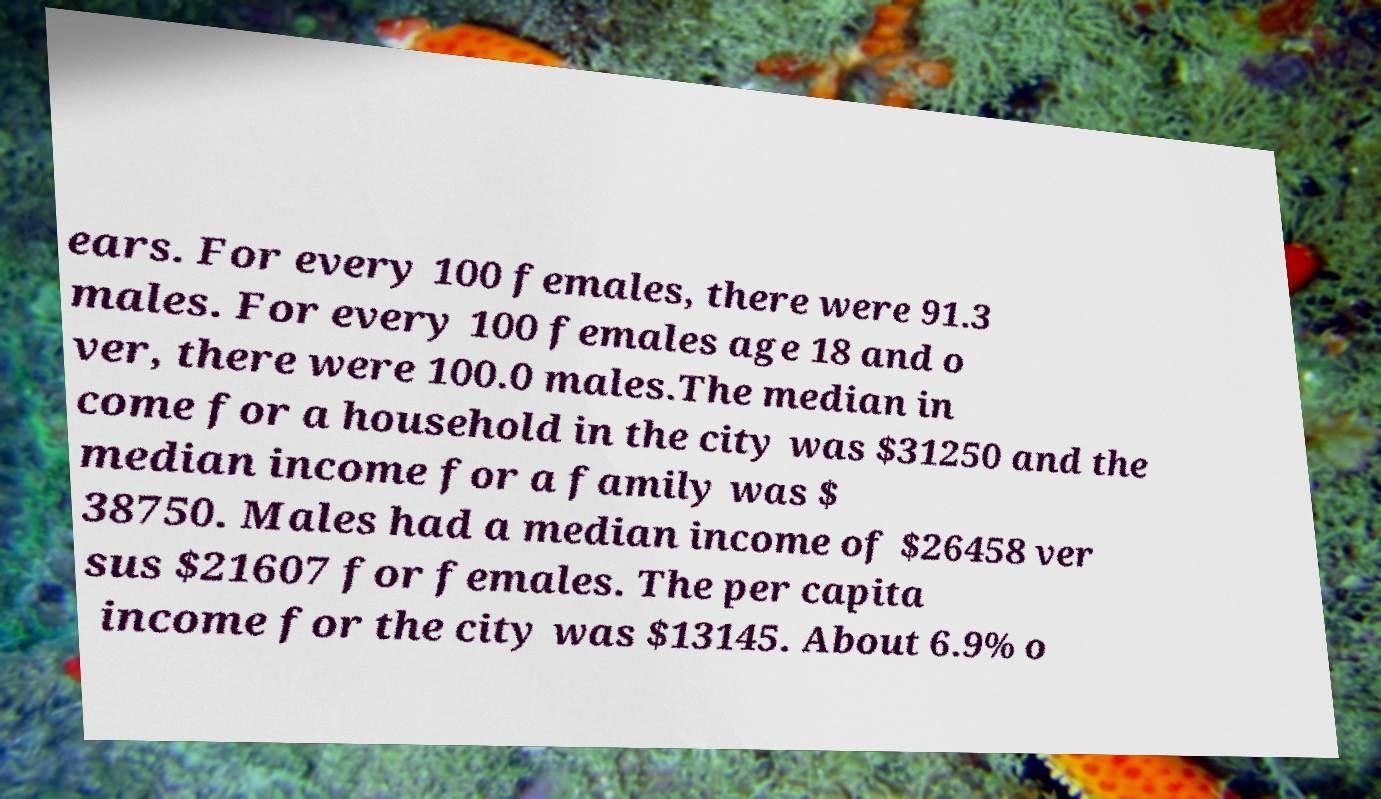What messages or text are displayed in this image? I need them in a readable, typed format. ears. For every 100 females, there were 91.3 males. For every 100 females age 18 and o ver, there were 100.0 males.The median in come for a household in the city was $31250 and the median income for a family was $ 38750. Males had a median income of $26458 ver sus $21607 for females. The per capita income for the city was $13145. About 6.9% o 